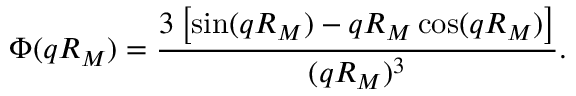<formula> <loc_0><loc_0><loc_500><loc_500>\Phi ( q R _ { M } ) = \frac { 3 \left [ \sin ( q R _ { M } ) - q R _ { M } \cos ( q R _ { M } ) \right ] } { ( q R _ { M } ) ^ { 3 } } .</formula> 